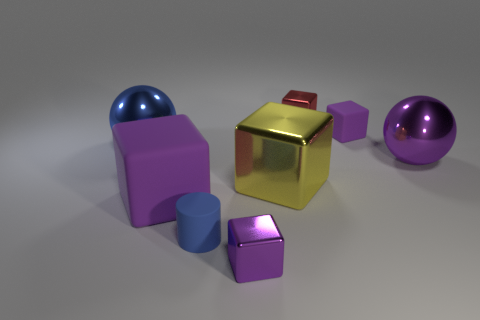Subtract all green balls. How many purple cubes are left? 3 Subtract 2 cubes. How many cubes are left? 3 Subtract all yellow blocks. How many blocks are left? 4 Subtract all big yellow shiny blocks. How many blocks are left? 4 Subtract all cyan blocks. Subtract all cyan cylinders. How many blocks are left? 5 Add 1 big purple cubes. How many objects exist? 9 Subtract all cylinders. How many objects are left? 7 Add 5 purple things. How many purple things are left? 9 Add 1 tiny yellow matte cubes. How many tiny yellow matte cubes exist? 1 Subtract 0 brown cylinders. How many objects are left? 8 